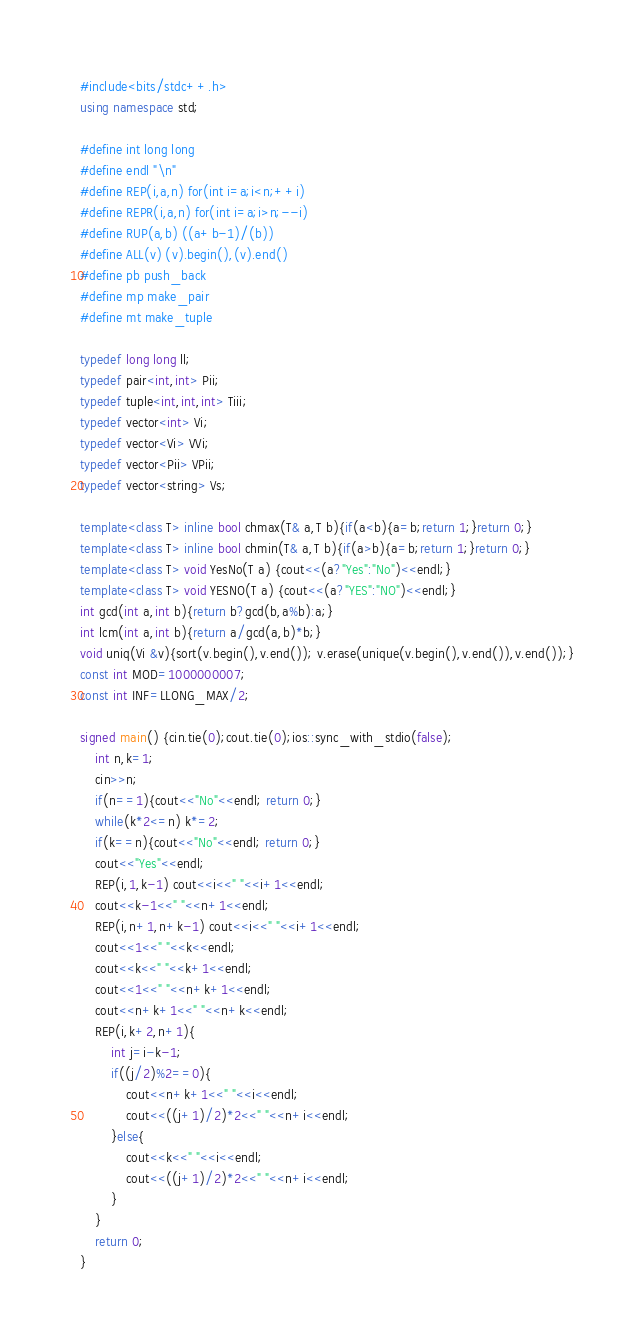<code> <loc_0><loc_0><loc_500><loc_500><_C++_>#include<bits/stdc++.h>
using namespace std;

#define int long long
#define endl "\n"
#define REP(i,a,n) for(int i=a;i<n;++i)
#define REPR(i,a,n) for(int i=a;i>n;--i)
#define RUP(a,b) ((a+b-1)/(b))
#define ALL(v) (v).begin(),(v).end()
#define pb push_back
#define mp make_pair
#define mt make_tuple

typedef long long ll;
typedef pair<int,int> Pii;
typedef tuple<int,int,int> Tiii;
typedef vector<int> Vi;
typedef vector<Vi> VVi;
typedef vector<Pii> VPii;
typedef vector<string> Vs;

template<class T> inline bool chmax(T& a,T b){if(a<b){a=b;return 1;}return 0;}
template<class T> inline bool chmin(T& a,T b){if(a>b){a=b;return 1;}return 0;}
template<class T> void YesNo(T a) {cout<<(a?"Yes":"No")<<endl;}
template<class T> void YESNO(T a) {cout<<(a?"YES":"NO")<<endl;}
int gcd(int a,int b){return b?gcd(b,a%b):a;}
int lcm(int a,int b){return a/gcd(a,b)*b;}
void uniq(Vi &v){sort(v.begin(),v.end()); v.erase(unique(v.begin(),v.end()),v.end());}
const int MOD=1000000007;
const int INF=LLONG_MAX/2;

signed main() {cin.tie(0);cout.tie(0);ios::sync_with_stdio(false);
    int n,k=1;
    cin>>n;
    if(n==1){cout<<"No"<<endl; return 0;}
    while(k*2<=n) k*=2;
    if(k==n){cout<<"No"<<endl; return 0;}
    cout<<"Yes"<<endl;
    REP(i,1,k-1) cout<<i<<" "<<i+1<<endl;
    cout<<k-1<<" "<<n+1<<endl;
    REP(i,n+1,n+k-1) cout<<i<<" "<<i+1<<endl;
    cout<<1<<" "<<k<<endl;
    cout<<k<<" "<<k+1<<endl;
    cout<<1<<" "<<n+k+1<<endl;
    cout<<n+k+1<<" "<<n+k<<endl;
    REP(i,k+2,n+1){
        int j=i-k-1;
        if((j/2)%2==0){
            cout<<n+k+1<<" "<<i<<endl;
            cout<<((j+1)/2)*2<<" "<<n+i<<endl;
        }else{
            cout<<k<<" "<<i<<endl;
            cout<<((j+1)/2)*2<<" "<<n+i<<endl;
        }
    }
    return 0;
}

</code> 